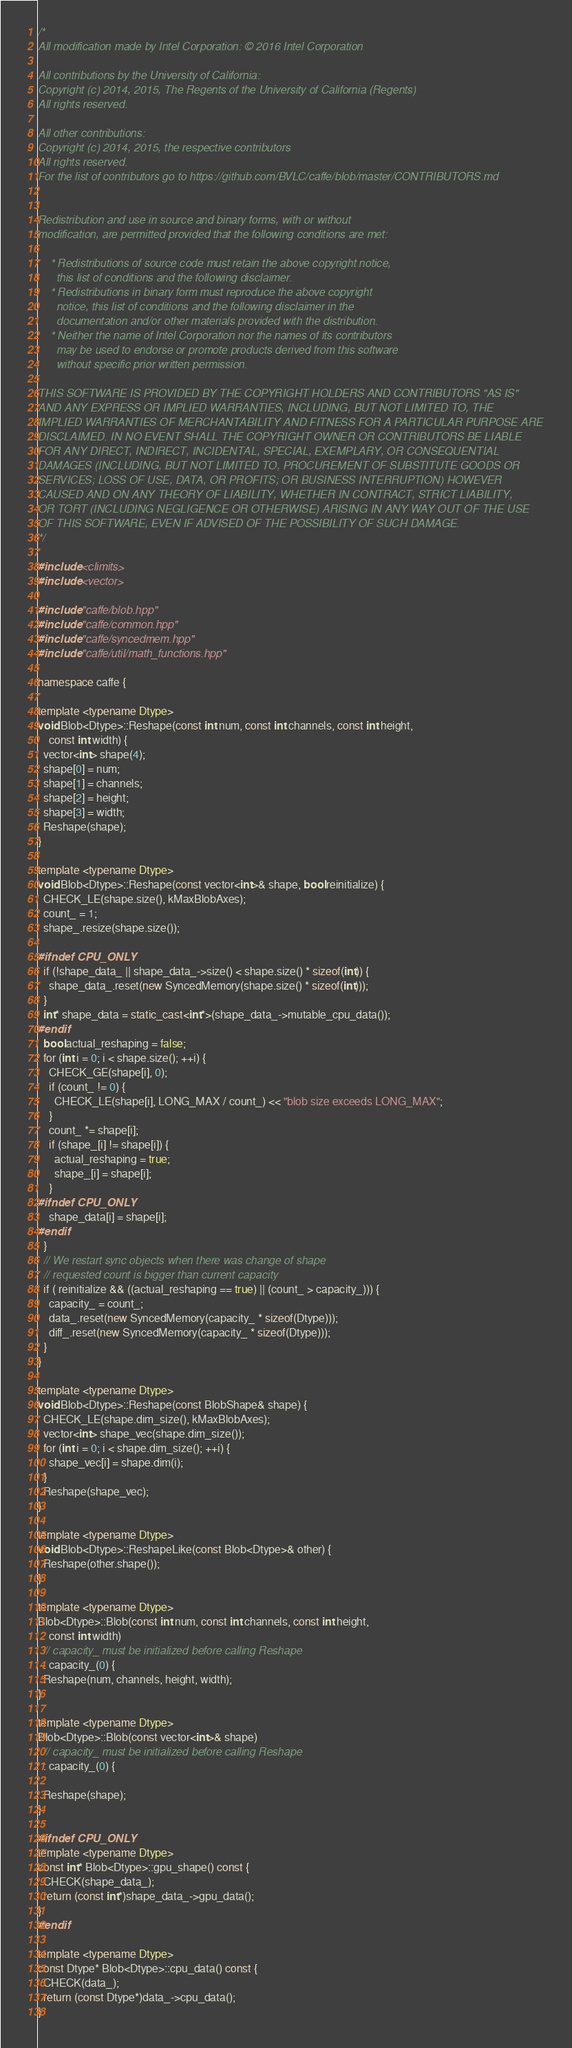Convert code to text. <code><loc_0><loc_0><loc_500><loc_500><_C++_>/*
All modification made by Intel Corporation: © 2016 Intel Corporation

All contributions by the University of California:
Copyright (c) 2014, 2015, The Regents of the University of California (Regents)
All rights reserved.

All other contributions:
Copyright (c) 2014, 2015, the respective contributors
All rights reserved.
For the list of contributors go to https://github.com/BVLC/caffe/blob/master/CONTRIBUTORS.md


Redistribution and use in source and binary forms, with or without
modification, are permitted provided that the following conditions are met:

    * Redistributions of source code must retain the above copyright notice,
      this list of conditions and the following disclaimer.
    * Redistributions in binary form must reproduce the above copyright
      notice, this list of conditions and the following disclaimer in the
      documentation and/or other materials provided with the distribution.
    * Neither the name of Intel Corporation nor the names of its contributors
      may be used to endorse or promote products derived from this software
      without specific prior written permission.

THIS SOFTWARE IS PROVIDED BY THE COPYRIGHT HOLDERS AND CONTRIBUTORS "AS IS"
AND ANY EXPRESS OR IMPLIED WARRANTIES, INCLUDING, BUT NOT LIMITED TO, THE
IMPLIED WARRANTIES OF MERCHANTABILITY AND FITNESS FOR A PARTICULAR PURPOSE ARE
DISCLAIMED. IN NO EVENT SHALL THE COPYRIGHT OWNER OR CONTRIBUTORS BE LIABLE
FOR ANY DIRECT, INDIRECT, INCIDENTAL, SPECIAL, EXEMPLARY, OR CONSEQUENTIAL
DAMAGES (INCLUDING, BUT NOT LIMITED TO, PROCUREMENT OF SUBSTITUTE GOODS OR
SERVICES; LOSS OF USE, DATA, OR PROFITS; OR BUSINESS INTERRUPTION) HOWEVER
CAUSED AND ON ANY THEORY OF LIABILITY, WHETHER IN CONTRACT, STRICT LIABILITY,
OR TORT (INCLUDING NEGLIGENCE OR OTHERWISE) ARISING IN ANY WAY OUT OF THE USE
OF THIS SOFTWARE, EVEN IF ADVISED OF THE POSSIBILITY OF SUCH DAMAGE.
*/

#include <climits>
#include <vector>

#include "caffe/blob.hpp"
#include "caffe/common.hpp"
#include "caffe/syncedmem.hpp"
#include "caffe/util/math_functions.hpp"

namespace caffe {

template <typename Dtype>
void Blob<Dtype>::Reshape(const int num, const int channels, const int height,
    const int width) {
  vector<int> shape(4);
  shape[0] = num;
  shape[1] = channels;
  shape[2] = height;
  shape[3] = width;
  Reshape(shape);
}

template <typename Dtype>
void Blob<Dtype>::Reshape(const vector<int>& shape, bool reinitialize) {
  CHECK_LE(shape.size(), kMaxBlobAxes);
  count_ = 1;
  shape_.resize(shape.size());

#ifndef CPU_ONLY
  if (!shape_data_ || shape_data_->size() < shape.size() * sizeof(int)) {
    shape_data_.reset(new SyncedMemory(shape.size() * sizeof(int)));
  }
  int* shape_data = static_cast<int*>(shape_data_->mutable_cpu_data());
#endif
  bool actual_reshaping = false;
  for (int i = 0; i < shape.size(); ++i) {
    CHECK_GE(shape[i], 0);
    if (count_ != 0) {
      CHECK_LE(shape[i], LONG_MAX / count_) << "blob size exceeds LONG_MAX";
    }
    count_ *= shape[i];
    if (shape_[i] != shape[i]) {
      actual_reshaping = true;
      shape_[i] = shape[i];
    }
#ifndef CPU_ONLY
    shape_data[i] = shape[i];
#endif
  }
  // We restart sync objects when there was change of shape
  // requested count is bigger than current capacity
  if ( reinitialize && ((actual_reshaping == true) || (count_ > capacity_))) {
    capacity_ = count_;
    data_.reset(new SyncedMemory(capacity_ * sizeof(Dtype)));
    diff_.reset(new SyncedMemory(capacity_ * sizeof(Dtype)));
  }
}

template <typename Dtype>
void Blob<Dtype>::Reshape(const BlobShape& shape) {
  CHECK_LE(shape.dim_size(), kMaxBlobAxes);
  vector<int> shape_vec(shape.dim_size());
  for (int i = 0; i < shape.dim_size(); ++i) {
    shape_vec[i] = shape.dim(i);
  }
  Reshape(shape_vec);
}

template <typename Dtype>
void Blob<Dtype>::ReshapeLike(const Blob<Dtype>& other) {
  Reshape(other.shape());
}

template <typename Dtype>
Blob<Dtype>::Blob(const int num, const int channels, const int height,
    const int width)
  // capacity_ must be initialized before calling Reshape
  : capacity_(0) {
  Reshape(num, channels, height, width);
}

template <typename Dtype>
Blob<Dtype>::Blob(const vector<int>& shape)
  // capacity_ must be initialized before calling Reshape
  : capacity_(0) {

  Reshape(shape);
}

#ifndef CPU_ONLY
template <typename Dtype>
const int* Blob<Dtype>::gpu_shape() const {
  CHECK(shape_data_);
  return (const int*)shape_data_->gpu_data();
}
#endif

template <typename Dtype>
const Dtype* Blob<Dtype>::cpu_data() const {
  CHECK(data_);
  return (const Dtype*)data_->cpu_data();
}
</code> 